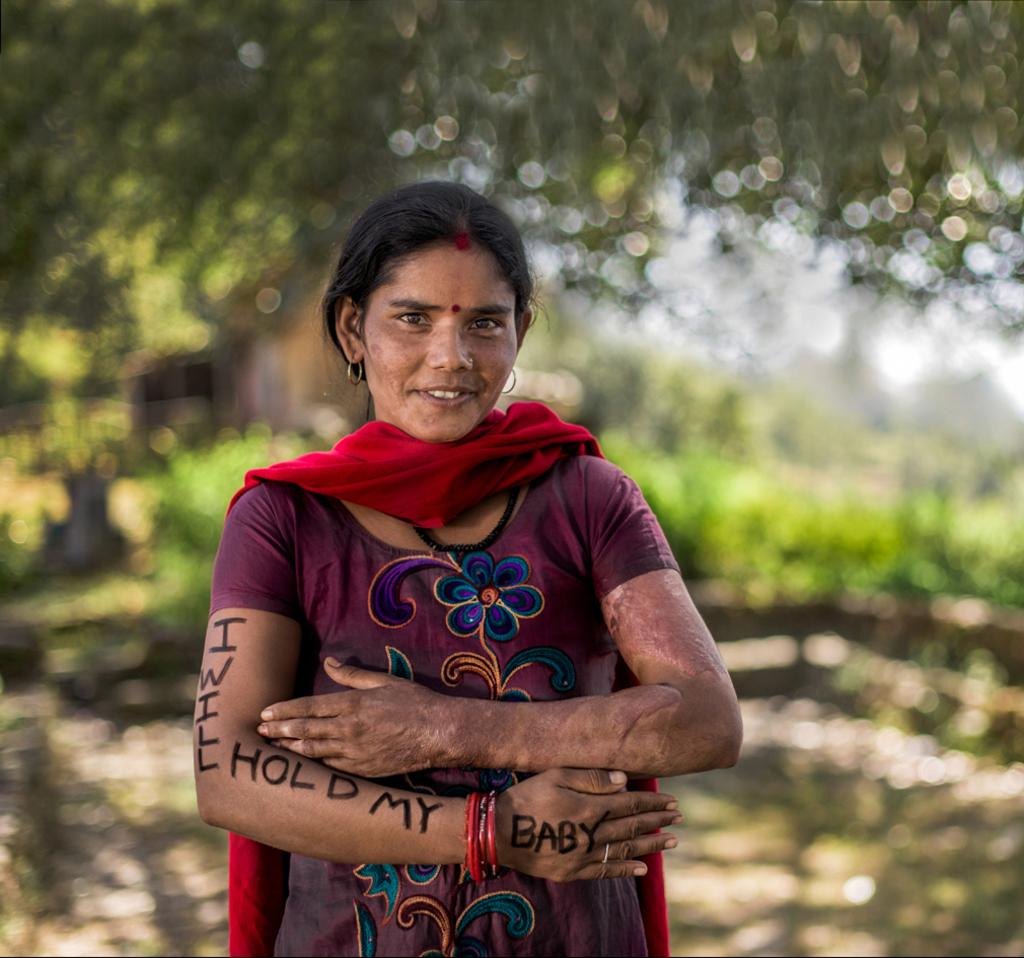What is the main subject in the foreground of the image? There is a woman in the foreground of the image. What is notable about the woman's appearance? The woman has text on her hand. What can be seen in the background of the image? There is greenery in the background of the image. How would you describe the overall quality of the image? The image is blurry. What type of whistle is the woman using in the image? There is no whistle present in the image. Is the woman painting her hand in the image? The woman has text on her hand, but there is no indication that she is painting it. 